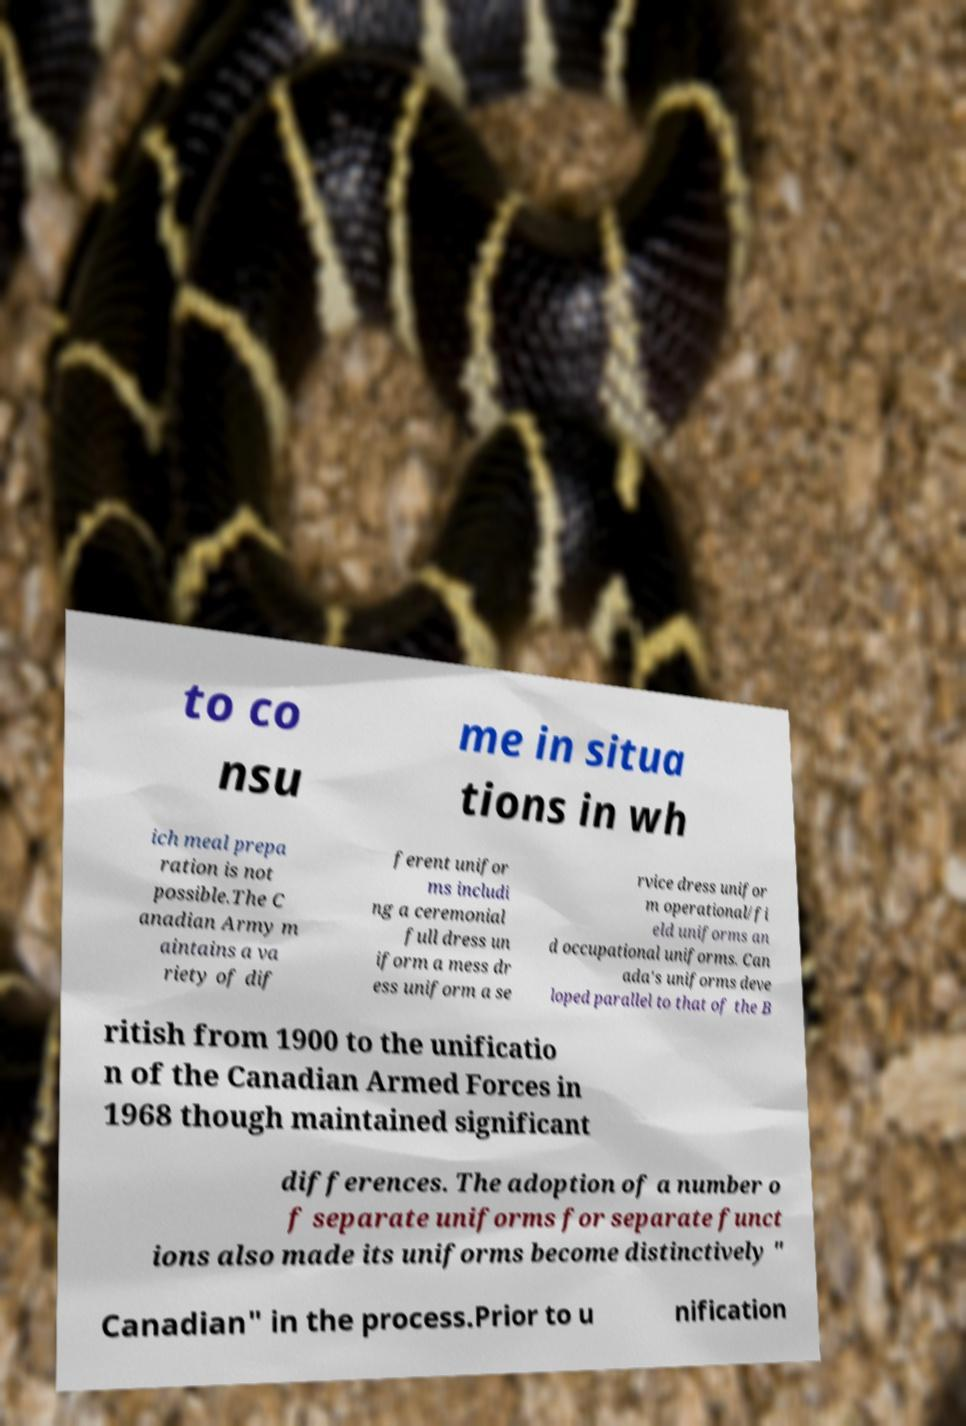There's text embedded in this image that I need extracted. Can you transcribe it verbatim? to co nsu me in situa tions in wh ich meal prepa ration is not possible.The C anadian Army m aintains a va riety of dif ferent unifor ms includi ng a ceremonial full dress un iform a mess dr ess uniform a se rvice dress unifor m operational/fi eld uniforms an d occupational uniforms. Can ada's uniforms deve loped parallel to that of the B ritish from 1900 to the unificatio n of the Canadian Armed Forces in 1968 though maintained significant differences. The adoption of a number o f separate uniforms for separate funct ions also made its uniforms become distinctively " Canadian" in the process.Prior to u nification 